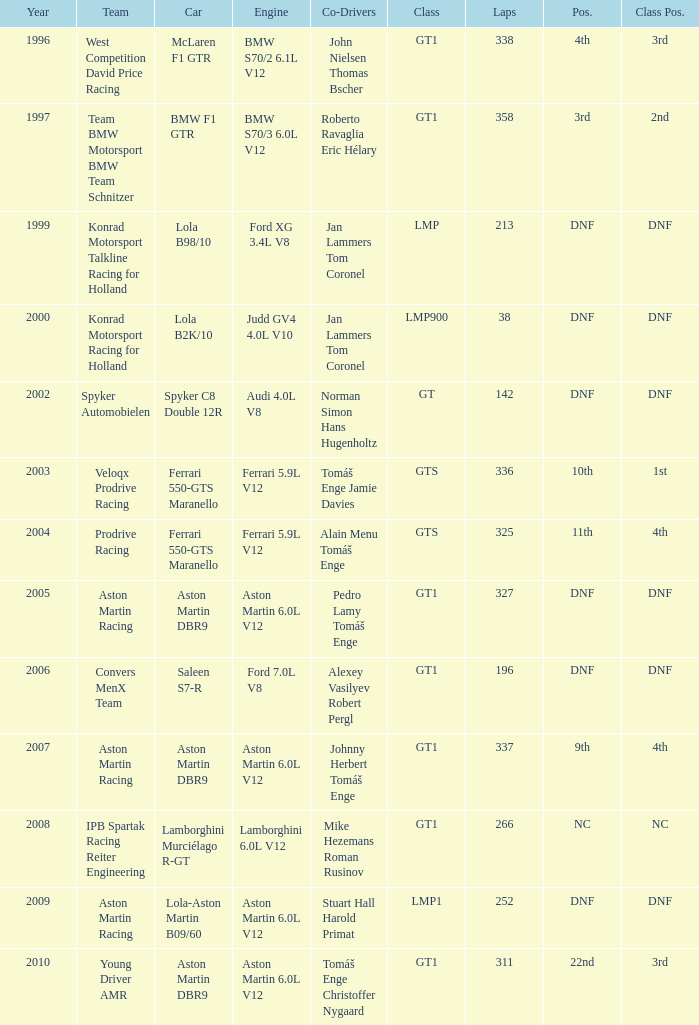What was the position in 1997? 3rd. 